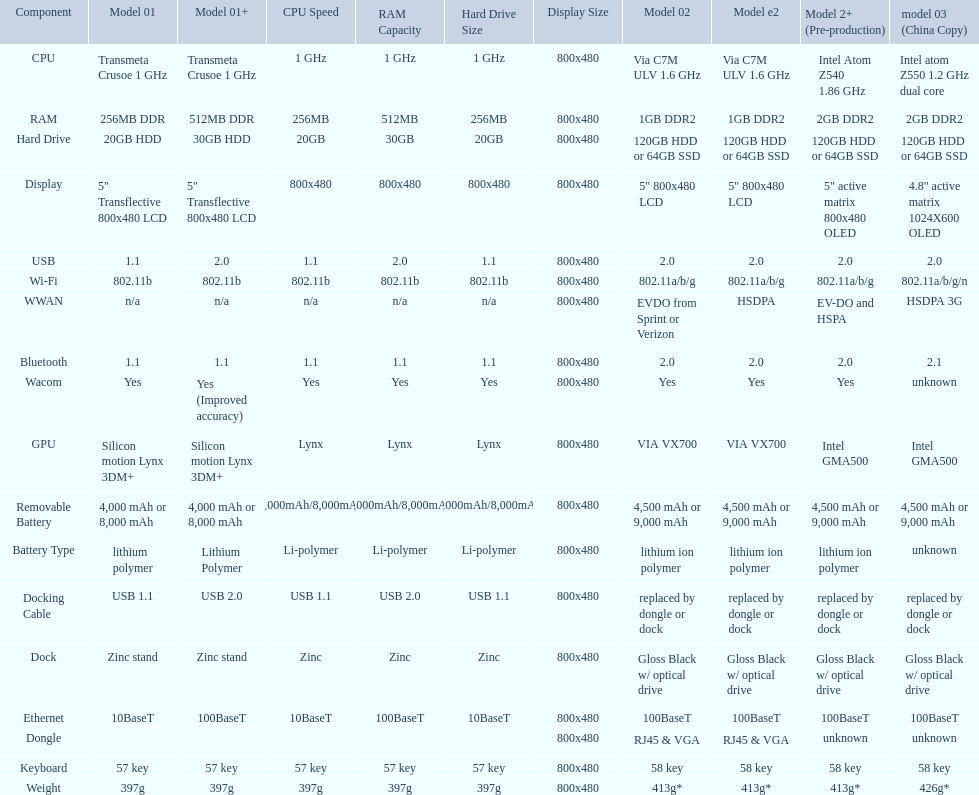How many models use a usb docking cable? 2. 